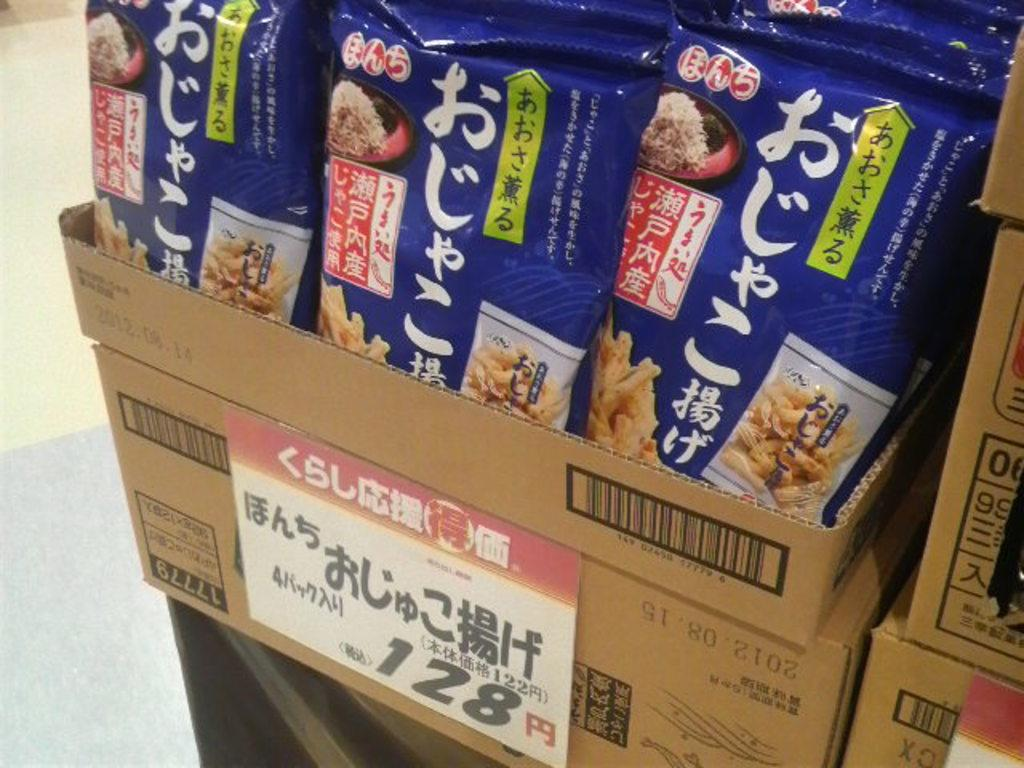How many boxes of snacks are visible in the image? There are three boxes of snacks in the image. Where are the boxes of snacks located? The boxes of snacks are on a table. What type of collar can be seen on the turkey in the image? There is no turkey or collar present in the image. 